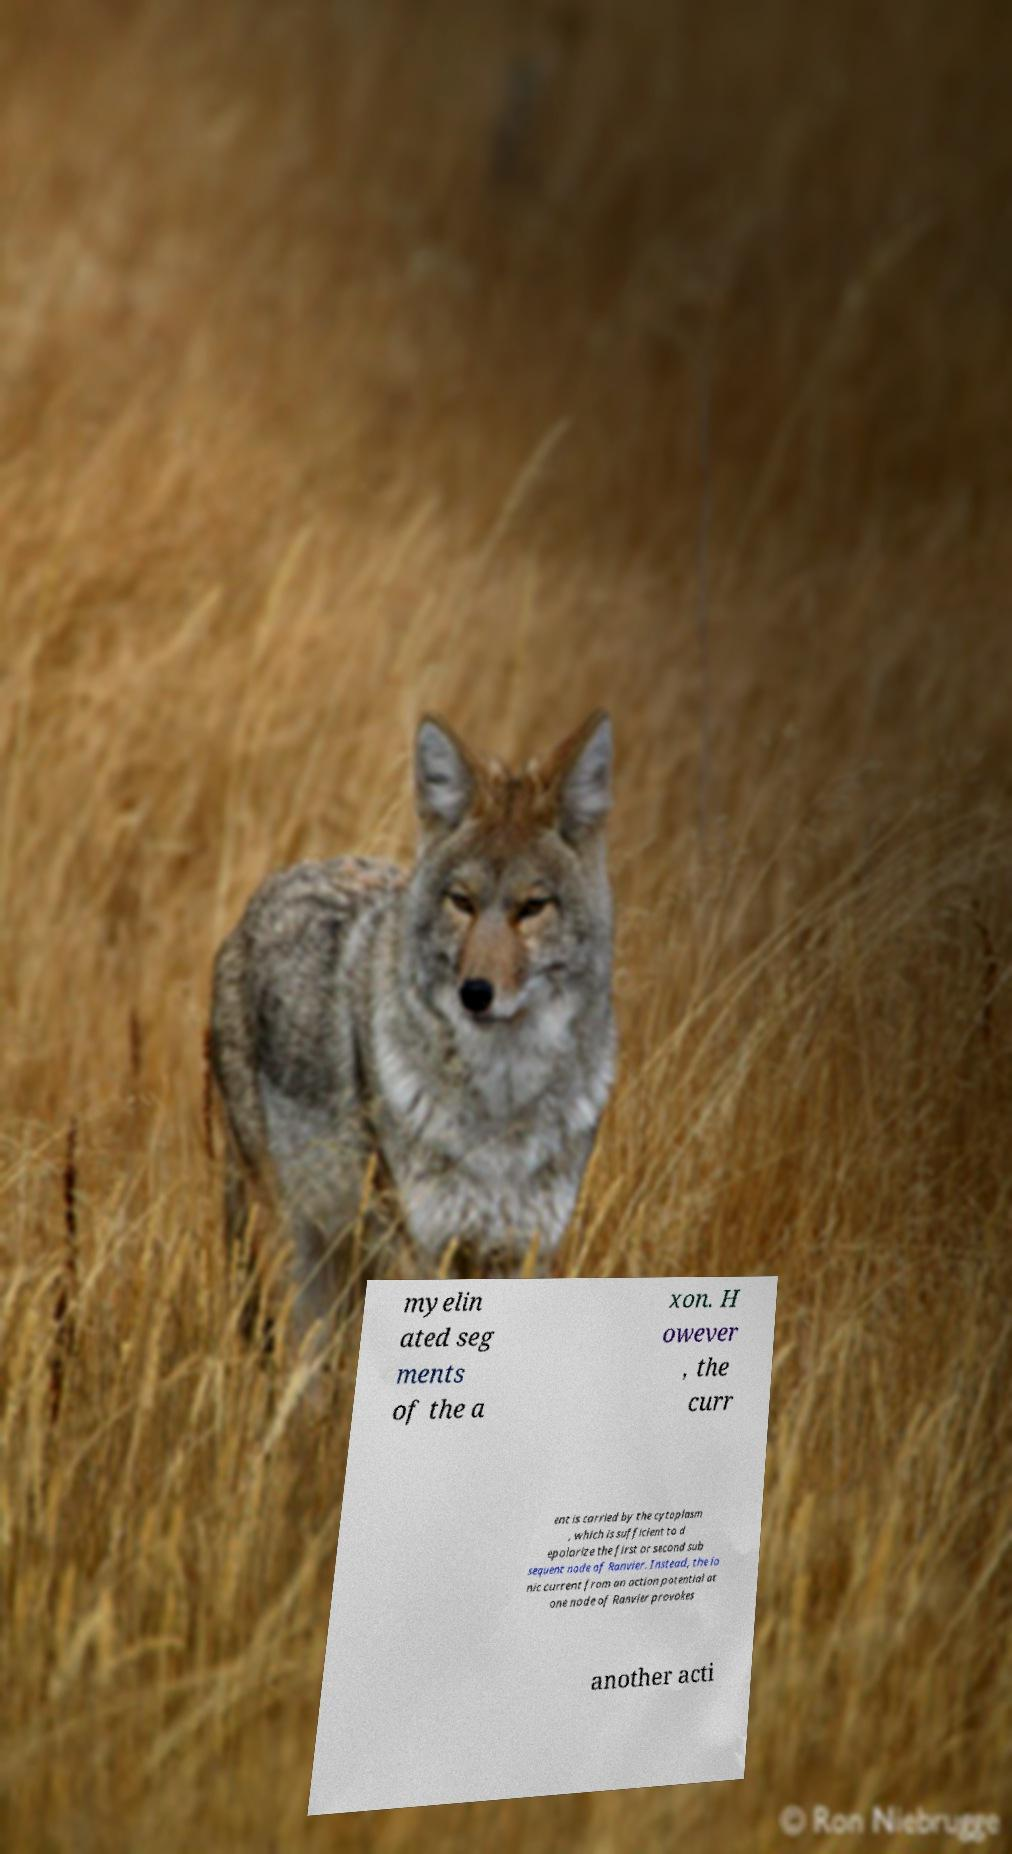Could you extract and type out the text from this image? myelin ated seg ments of the a xon. H owever , the curr ent is carried by the cytoplasm , which is sufficient to d epolarize the first or second sub sequent node of Ranvier. Instead, the io nic current from an action potential at one node of Ranvier provokes another acti 